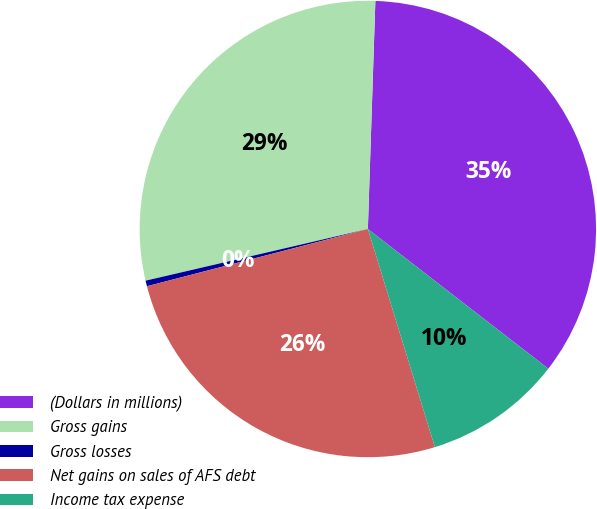Convert chart. <chart><loc_0><loc_0><loc_500><loc_500><pie_chart><fcel>(Dollars in millions)<fcel>Gross gains<fcel>Gross losses<fcel>Net gains on sales of AFS debt<fcel>Income tax expense<nl><fcel>34.96%<fcel>29.16%<fcel>0.4%<fcel>25.71%<fcel>9.77%<nl></chart> 